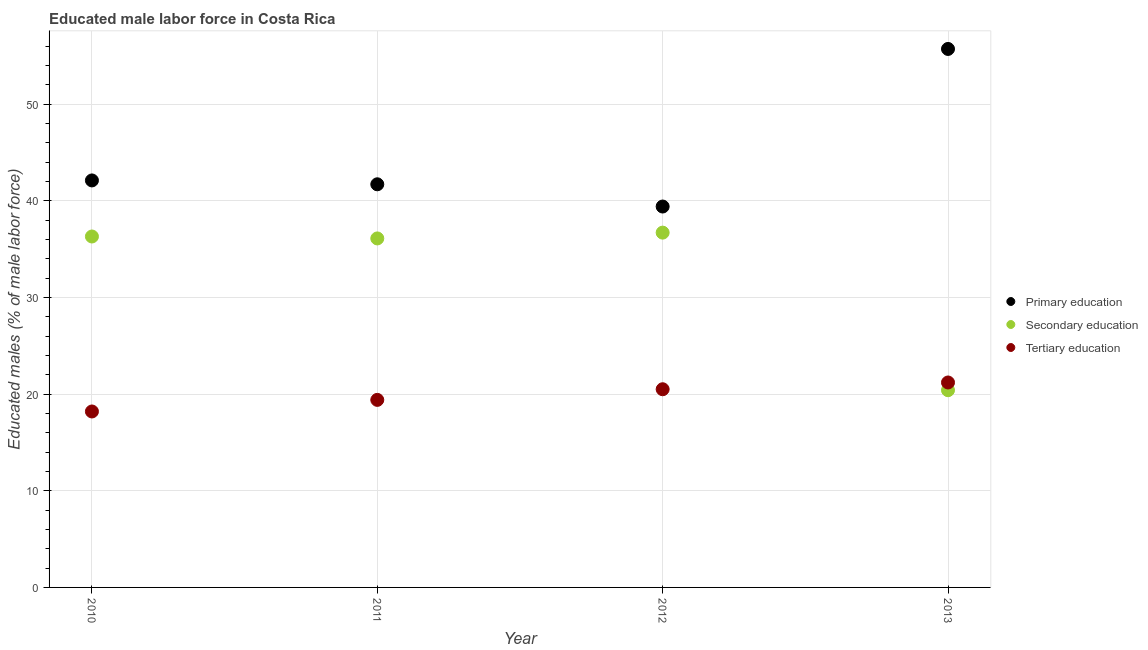How many different coloured dotlines are there?
Offer a terse response. 3. What is the percentage of male labor force who received tertiary education in 2012?
Provide a succinct answer. 20.5. Across all years, what is the maximum percentage of male labor force who received primary education?
Give a very brief answer. 55.7. Across all years, what is the minimum percentage of male labor force who received tertiary education?
Give a very brief answer. 18.2. What is the total percentage of male labor force who received tertiary education in the graph?
Ensure brevity in your answer.  79.3. What is the difference between the percentage of male labor force who received tertiary education in 2012 and that in 2013?
Keep it short and to the point. -0.7. What is the difference between the percentage of male labor force who received secondary education in 2011 and the percentage of male labor force who received tertiary education in 2012?
Keep it short and to the point. 15.6. What is the average percentage of male labor force who received tertiary education per year?
Your answer should be very brief. 19.83. In the year 2012, what is the difference between the percentage of male labor force who received primary education and percentage of male labor force who received tertiary education?
Offer a very short reply. 18.9. In how many years, is the percentage of male labor force who received primary education greater than 44 %?
Ensure brevity in your answer.  1. What is the ratio of the percentage of male labor force who received primary education in 2010 to that in 2013?
Keep it short and to the point. 0.76. Is the percentage of male labor force who received primary education in 2011 less than that in 2013?
Make the answer very short. Yes. What is the difference between the highest and the second highest percentage of male labor force who received secondary education?
Make the answer very short. 0.4. What is the difference between the highest and the lowest percentage of male labor force who received tertiary education?
Make the answer very short. 3. Is the percentage of male labor force who received primary education strictly greater than the percentage of male labor force who received secondary education over the years?
Your answer should be compact. Yes. Is the percentage of male labor force who received tertiary education strictly less than the percentage of male labor force who received secondary education over the years?
Ensure brevity in your answer.  No. How many years are there in the graph?
Your answer should be compact. 4. What is the difference between two consecutive major ticks on the Y-axis?
Your response must be concise. 10. How many legend labels are there?
Offer a very short reply. 3. What is the title of the graph?
Provide a short and direct response. Educated male labor force in Costa Rica. What is the label or title of the X-axis?
Ensure brevity in your answer.  Year. What is the label or title of the Y-axis?
Keep it short and to the point. Educated males (% of male labor force). What is the Educated males (% of male labor force) in Primary education in 2010?
Offer a terse response. 42.1. What is the Educated males (% of male labor force) in Secondary education in 2010?
Make the answer very short. 36.3. What is the Educated males (% of male labor force) of Tertiary education in 2010?
Make the answer very short. 18.2. What is the Educated males (% of male labor force) of Primary education in 2011?
Your answer should be compact. 41.7. What is the Educated males (% of male labor force) in Secondary education in 2011?
Your response must be concise. 36.1. What is the Educated males (% of male labor force) in Tertiary education in 2011?
Offer a terse response. 19.4. What is the Educated males (% of male labor force) of Primary education in 2012?
Provide a short and direct response. 39.4. What is the Educated males (% of male labor force) of Secondary education in 2012?
Keep it short and to the point. 36.7. What is the Educated males (% of male labor force) in Tertiary education in 2012?
Your answer should be very brief. 20.5. What is the Educated males (% of male labor force) in Primary education in 2013?
Offer a very short reply. 55.7. What is the Educated males (% of male labor force) of Secondary education in 2013?
Keep it short and to the point. 20.4. What is the Educated males (% of male labor force) in Tertiary education in 2013?
Give a very brief answer. 21.2. Across all years, what is the maximum Educated males (% of male labor force) of Primary education?
Offer a very short reply. 55.7. Across all years, what is the maximum Educated males (% of male labor force) of Secondary education?
Your answer should be very brief. 36.7. Across all years, what is the maximum Educated males (% of male labor force) in Tertiary education?
Make the answer very short. 21.2. Across all years, what is the minimum Educated males (% of male labor force) of Primary education?
Your answer should be compact. 39.4. Across all years, what is the minimum Educated males (% of male labor force) in Secondary education?
Keep it short and to the point. 20.4. Across all years, what is the minimum Educated males (% of male labor force) in Tertiary education?
Your answer should be compact. 18.2. What is the total Educated males (% of male labor force) in Primary education in the graph?
Your answer should be very brief. 178.9. What is the total Educated males (% of male labor force) of Secondary education in the graph?
Offer a terse response. 129.5. What is the total Educated males (% of male labor force) of Tertiary education in the graph?
Provide a succinct answer. 79.3. What is the difference between the Educated males (% of male labor force) of Primary education in 2010 and that in 2011?
Your response must be concise. 0.4. What is the difference between the Educated males (% of male labor force) in Secondary education in 2010 and that in 2011?
Offer a terse response. 0.2. What is the difference between the Educated males (% of male labor force) of Tertiary education in 2010 and that in 2011?
Provide a succinct answer. -1.2. What is the difference between the Educated males (% of male labor force) of Primary education in 2010 and that in 2012?
Ensure brevity in your answer.  2.7. What is the difference between the Educated males (% of male labor force) of Secondary education in 2010 and that in 2012?
Provide a succinct answer. -0.4. What is the difference between the Educated males (% of male labor force) in Secondary education in 2010 and that in 2013?
Your response must be concise. 15.9. What is the difference between the Educated males (% of male labor force) of Primary education in 2011 and that in 2012?
Offer a very short reply. 2.3. What is the difference between the Educated males (% of male labor force) of Tertiary education in 2011 and that in 2012?
Your answer should be very brief. -1.1. What is the difference between the Educated males (% of male labor force) of Primary education in 2011 and that in 2013?
Your answer should be compact. -14. What is the difference between the Educated males (% of male labor force) in Secondary education in 2011 and that in 2013?
Your response must be concise. 15.7. What is the difference between the Educated males (% of male labor force) in Tertiary education in 2011 and that in 2013?
Provide a succinct answer. -1.8. What is the difference between the Educated males (% of male labor force) of Primary education in 2012 and that in 2013?
Ensure brevity in your answer.  -16.3. What is the difference between the Educated males (% of male labor force) of Primary education in 2010 and the Educated males (% of male labor force) of Secondary education in 2011?
Provide a short and direct response. 6. What is the difference between the Educated males (% of male labor force) in Primary education in 2010 and the Educated males (% of male labor force) in Tertiary education in 2011?
Give a very brief answer. 22.7. What is the difference between the Educated males (% of male labor force) of Secondary education in 2010 and the Educated males (% of male labor force) of Tertiary education in 2011?
Offer a terse response. 16.9. What is the difference between the Educated males (% of male labor force) in Primary education in 2010 and the Educated males (% of male labor force) in Tertiary education in 2012?
Offer a terse response. 21.6. What is the difference between the Educated males (% of male labor force) of Primary education in 2010 and the Educated males (% of male labor force) of Secondary education in 2013?
Offer a very short reply. 21.7. What is the difference between the Educated males (% of male labor force) in Primary education in 2010 and the Educated males (% of male labor force) in Tertiary education in 2013?
Keep it short and to the point. 20.9. What is the difference between the Educated males (% of male labor force) of Secondary education in 2010 and the Educated males (% of male labor force) of Tertiary education in 2013?
Your answer should be very brief. 15.1. What is the difference between the Educated males (% of male labor force) in Primary education in 2011 and the Educated males (% of male labor force) in Tertiary education in 2012?
Make the answer very short. 21.2. What is the difference between the Educated males (% of male labor force) in Secondary education in 2011 and the Educated males (% of male labor force) in Tertiary education in 2012?
Your response must be concise. 15.6. What is the difference between the Educated males (% of male labor force) of Primary education in 2011 and the Educated males (% of male labor force) of Secondary education in 2013?
Provide a succinct answer. 21.3. What is the difference between the Educated males (% of male labor force) of Primary education in 2011 and the Educated males (% of male labor force) of Tertiary education in 2013?
Provide a succinct answer. 20.5. What is the difference between the Educated males (% of male labor force) of Secondary education in 2011 and the Educated males (% of male labor force) of Tertiary education in 2013?
Provide a short and direct response. 14.9. What is the average Educated males (% of male labor force) of Primary education per year?
Your answer should be compact. 44.73. What is the average Educated males (% of male labor force) of Secondary education per year?
Offer a very short reply. 32.38. What is the average Educated males (% of male labor force) in Tertiary education per year?
Offer a terse response. 19.82. In the year 2010, what is the difference between the Educated males (% of male labor force) of Primary education and Educated males (% of male labor force) of Secondary education?
Your answer should be very brief. 5.8. In the year 2010, what is the difference between the Educated males (% of male labor force) of Primary education and Educated males (% of male labor force) of Tertiary education?
Give a very brief answer. 23.9. In the year 2011, what is the difference between the Educated males (% of male labor force) in Primary education and Educated males (% of male labor force) in Secondary education?
Give a very brief answer. 5.6. In the year 2011, what is the difference between the Educated males (% of male labor force) of Primary education and Educated males (% of male labor force) of Tertiary education?
Your answer should be very brief. 22.3. In the year 2012, what is the difference between the Educated males (% of male labor force) of Primary education and Educated males (% of male labor force) of Secondary education?
Your response must be concise. 2.7. In the year 2012, what is the difference between the Educated males (% of male labor force) of Primary education and Educated males (% of male labor force) of Tertiary education?
Offer a very short reply. 18.9. In the year 2013, what is the difference between the Educated males (% of male labor force) in Primary education and Educated males (% of male labor force) in Secondary education?
Make the answer very short. 35.3. In the year 2013, what is the difference between the Educated males (% of male labor force) of Primary education and Educated males (% of male labor force) of Tertiary education?
Keep it short and to the point. 34.5. What is the ratio of the Educated males (% of male labor force) of Primary education in 2010 to that in 2011?
Your answer should be very brief. 1.01. What is the ratio of the Educated males (% of male labor force) in Secondary education in 2010 to that in 2011?
Ensure brevity in your answer.  1.01. What is the ratio of the Educated males (% of male labor force) of Tertiary education in 2010 to that in 2011?
Your answer should be very brief. 0.94. What is the ratio of the Educated males (% of male labor force) in Primary education in 2010 to that in 2012?
Provide a short and direct response. 1.07. What is the ratio of the Educated males (% of male labor force) in Tertiary education in 2010 to that in 2012?
Make the answer very short. 0.89. What is the ratio of the Educated males (% of male labor force) in Primary education in 2010 to that in 2013?
Give a very brief answer. 0.76. What is the ratio of the Educated males (% of male labor force) of Secondary education in 2010 to that in 2013?
Your answer should be very brief. 1.78. What is the ratio of the Educated males (% of male labor force) in Tertiary education in 2010 to that in 2013?
Ensure brevity in your answer.  0.86. What is the ratio of the Educated males (% of male labor force) in Primary education in 2011 to that in 2012?
Ensure brevity in your answer.  1.06. What is the ratio of the Educated males (% of male labor force) in Secondary education in 2011 to that in 2012?
Your answer should be very brief. 0.98. What is the ratio of the Educated males (% of male labor force) of Tertiary education in 2011 to that in 2012?
Offer a very short reply. 0.95. What is the ratio of the Educated males (% of male labor force) of Primary education in 2011 to that in 2013?
Keep it short and to the point. 0.75. What is the ratio of the Educated males (% of male labor force) in Secondary education in 2011 to that in 2013?
Offer a very short reply. 1.77. What is the ratio of the Educated males (% of male labor force) in Tertiary education in 2011 to that in 2013?
Offer a terse response. 0.92. What is the ratio of the Educated males (% of male labor force) in Primary education in 2012 to that in 2013?
Your response must be concise. 0.71. What is the ratio of the Educated males (% of male labor force) of Secondary education in 2012 to that in 2013?
Provide a short and direct response. 1.8. What is the difference between the highest and the second highest Educated males (% of male labor force) in Primary education?
Your answer should be very brief. 13.6. What is the difference between the highest and the lowest Educated males (% of male labor force) in Secondary education?
Ensure brevity in your answer.  16.3. What is the difference between the highest and the lowest Educated males (% of male labor force) in Tertiary education?
Your answer should be very brief. 3. 